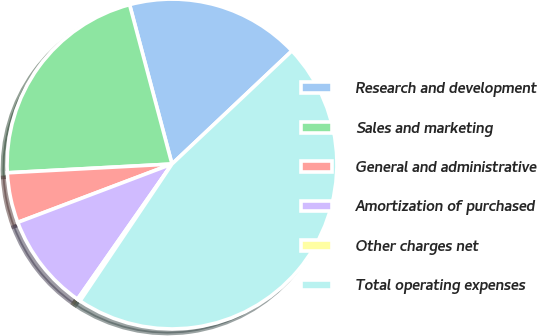<chart> <loc_0><loc_0><loc_500><loc_500><pie_chart><fcel>Research and development<fcel>Sales and marketing<fcel>General and administrative<fcel>Amortization of purchased<fcel>Other charges net<fcel>Total operating expenses<nl><fcel>17.1%<fcel>21.71%<fcel>4.91%<fcel>9.53%<fcel>0.3%<fcel>46.45%<nl></chart> 